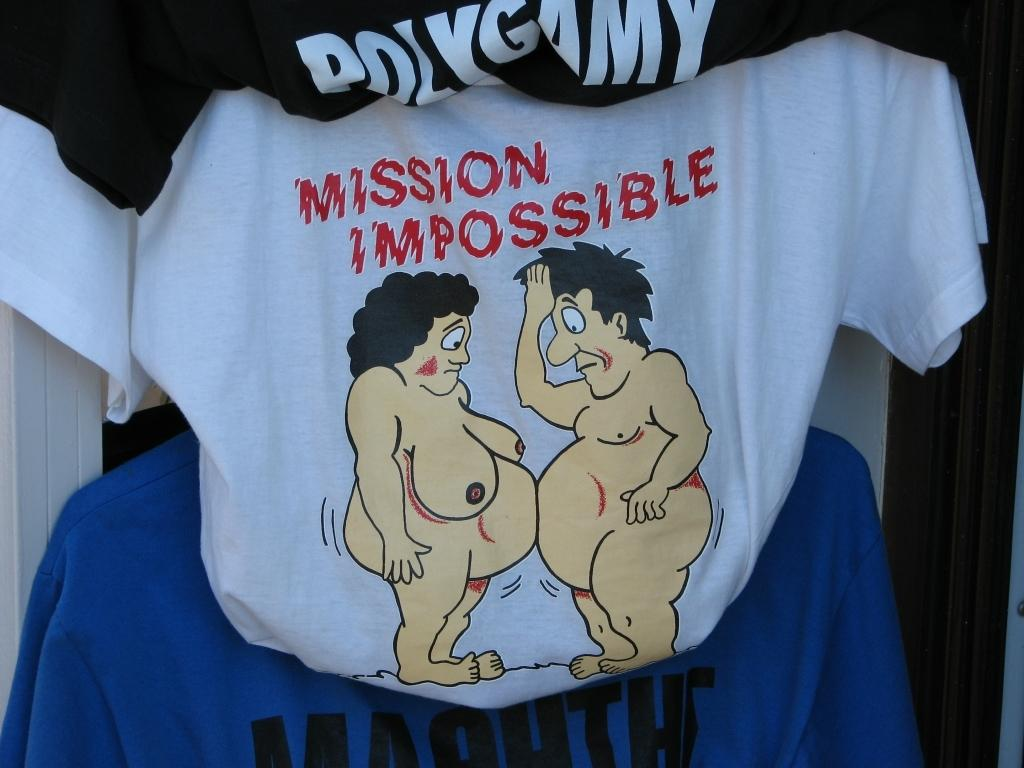<image>
Relay a brief, clear account of the picture shown. A t-shirt cartoon with two large-bellied people says Mission Impossible at the top. 